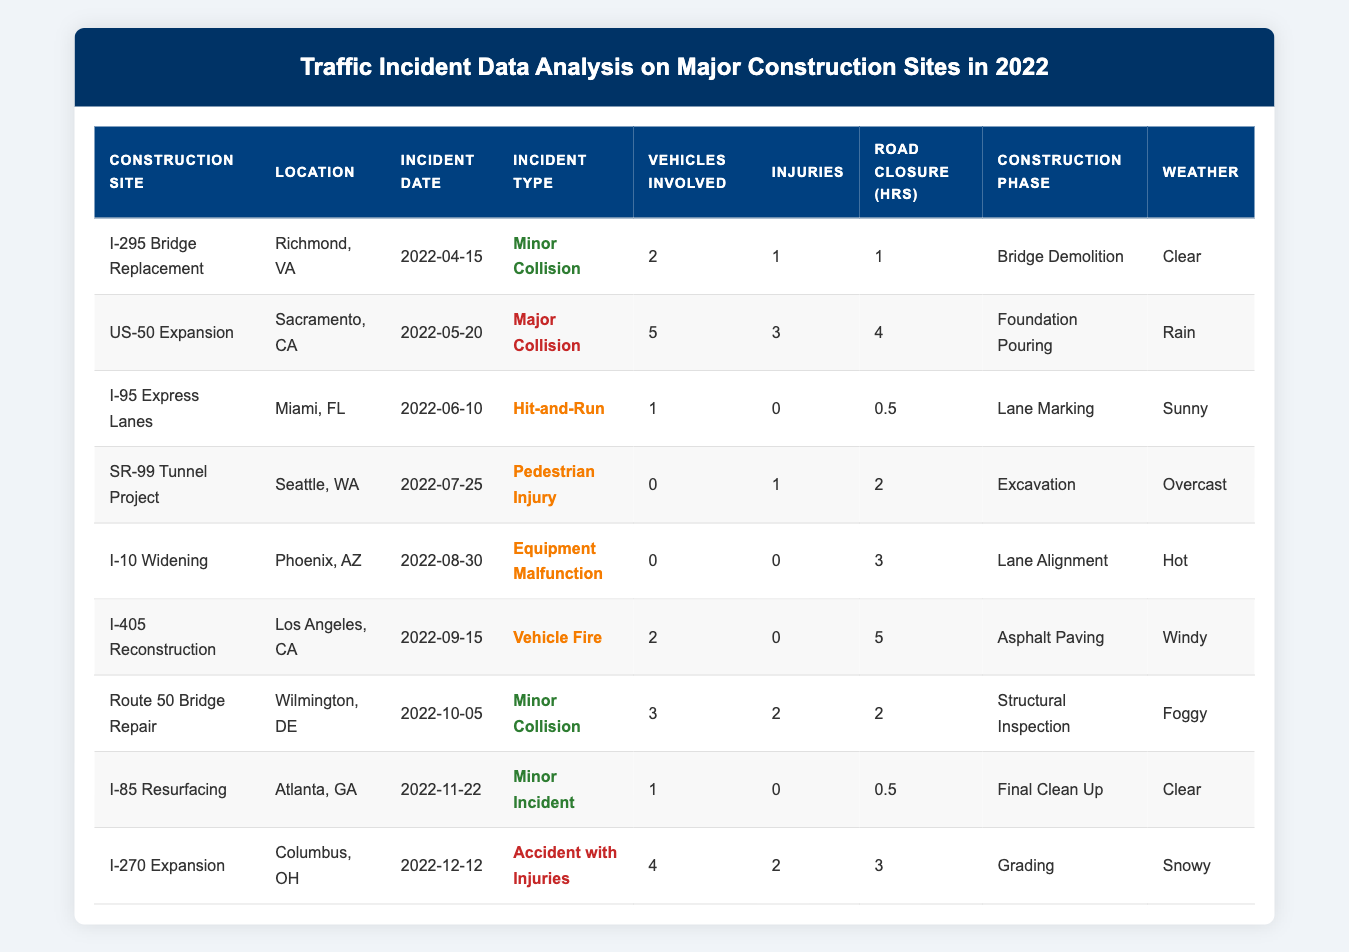What is the incident type for the I-295 Bridge Replacement? Looking at the table, I can find the row for the "I-295 Bridge Replacement" and see that the "Incident Type" listed is "Minor Collision."
Answer: Minor Collision How many vehicles were involved in the US-50 Expansion incident? In the row for "US-50 Expansion," it shows that "Vehicles Involved" is 5.
Answer: 5 What was the weather condition during the incident at the I-95 Express Lanes? By checking the "I-95 Express Lanes" row, I see the "Weather" condition listed is "Sunny."
Answer: Sunny What was the longest road closure duration recorded among these incidents? To find the longest road closure, I look for the maximum value in the "Road Closure (hrs)" column, which has values of 1, 4, 0.5, 2, 3, 5, 2, 0.5, and 3. The maximum is 5 hours for the "I-405 Reconstruction" incident.
Answer: 5 hours How many injuries were reported across all incidents? I add up the values in the "Injuries" column: 1 + 3 + 0 + 1 + 0 + 0 + 2 + 0 + 2 = 9.
Answer: 9 What is the construction phase for the SR-99 Tunnel Project? In the table, the row for "SR-99 Tunnel Project" indicates that the "Construction Phase" is "Excavation."
Answer: Excavation Was there a minor incident reported on I-85 Resurfacing? By examining the "I-85 Resurfacing" row, I find that the "Incident Type" is "Minor Incident," confirming that there was a minor incident.
Answer: Yes How many incidents reported injuries at construction sites under overcast weather? The "SR-99 Tunnel Project" shows 1 injury reported during "Excavation" on "Overcast" weather, and no other incidents reported under this weather condition. Therefore, the total is 1 incident.
Answer: 1 What is the average number of vehicles involved in minor incidents? I check the rows marked as "Minor Collision" and "Minor Incident," counting 4 incidents with 2, 3, 1, and 0 vehicles involved. The sum is (2 + 3 + 1 + 1) = 7, and there are 4 incidents, so the average is 7/4 = 1.75.
Answer: 1.75 Which incident type resulted in the highest number of vehicles involved? Reviewing the table, I identify the "US-50 Expansion" incident as the one with the maximum vehicles involved, totaling 5.
Answer: Major Collision How many total incidents occurred in clear weather conditions? I scan the table for rows where "Weather" is "Clear," finding 3 incidents listed under this condition.
Answer: 3 